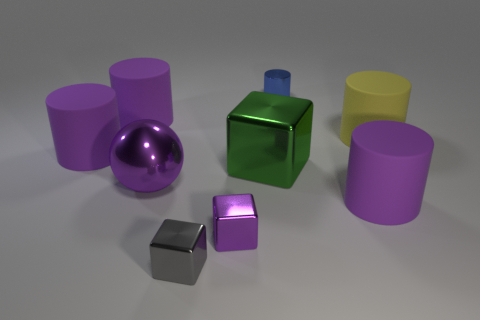The tiny cylinder that is the same material as the small purple thing is what color?
Offer a terse response. Blue. What number of large green cubes are the same material as the blue cylinder?
Offer a very short reply. 1. There is a big metallic ball; is its color the same as the tiny cube to the right of the small gray cube?
Ensure brevity in your answer.  Yes. What color is the tiny thing that is behind the big metallic object that is on the right side of the metal ball?
Give a very brief answer. Blue. What is the color of the shiny block that is the same size as the purple metallic sphere?
Give a very brief answer. Green. Is there another thing of the same shape as the tiny gray object?
Ensure brevity in your answer.  Yes. What is the shape of the tiny blue object?
Provide a succinct answer. Cylinder. Is the number of big yellow rubber things behind the tiny gray thing greater than the number of green shiny things in front of the green metallic thing?
Offer a very short reply. Yes. How many other objects are there of the same size as the blue shiny cylinder?
Give a very brief answer. 2. What is the material of the object that is both on the right side of the blue metallic cylinder and behind the purple ball?
Your answer should be very brief. Rubber. 